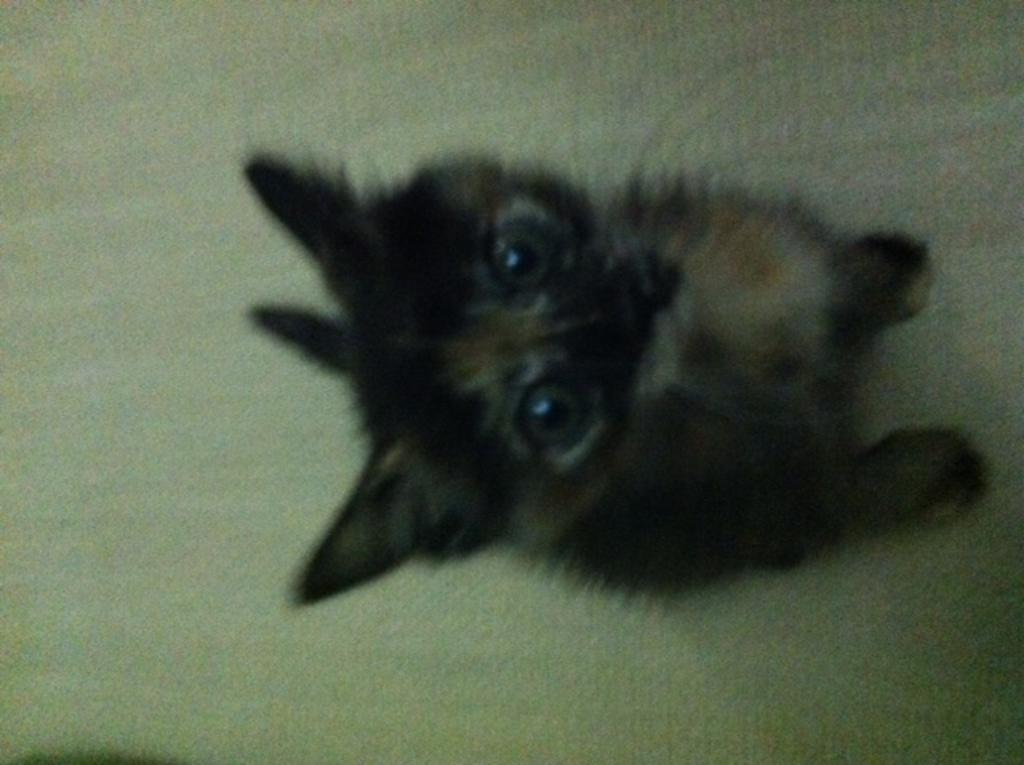What type of animal is in the image? There is a cat in the image. Can you describe the coloring of the cat? The cat has black and brown coloring. What is the cat sitting on in the image? The cat is on a green surface. What is the name of the fireman in the image? There is no fireman present in the image; it features a cat with black and brown coloring sitting on a green surface. How many ants can be seen crawling on the cat in the image? There are no ants present in the image; it features a cat with black and brown coloring sitting on a green surface. 